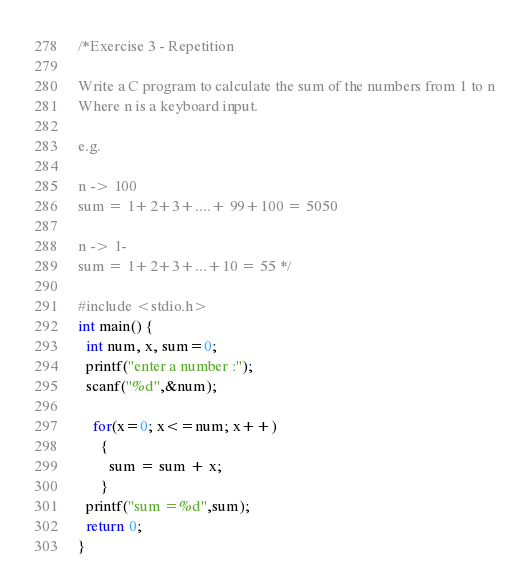Convert code to text. <code><loc_0><loc_0><loc_500><loc_500><_C_>/*Exercise 3 - Repetition

Write a C program to calculate the sum of the numbers from 1 to n
Where n is a keyboard input.

e.g.

n -> 100
sum = 1+2+3+....+ 99+100 = 5050

n -> 1-
sum = 1+2+3+...+10 = 55 */

#include <stdio.h>
int main() {
  int num, x, sum=0;
  printf("enter a number :");
  scanf("%d",&num);

    for(x=0; x<=num; x++)
      {
        sum = sum + x;
      }
  printf("sum =%d",sum);
  return 0;
}

</code> 